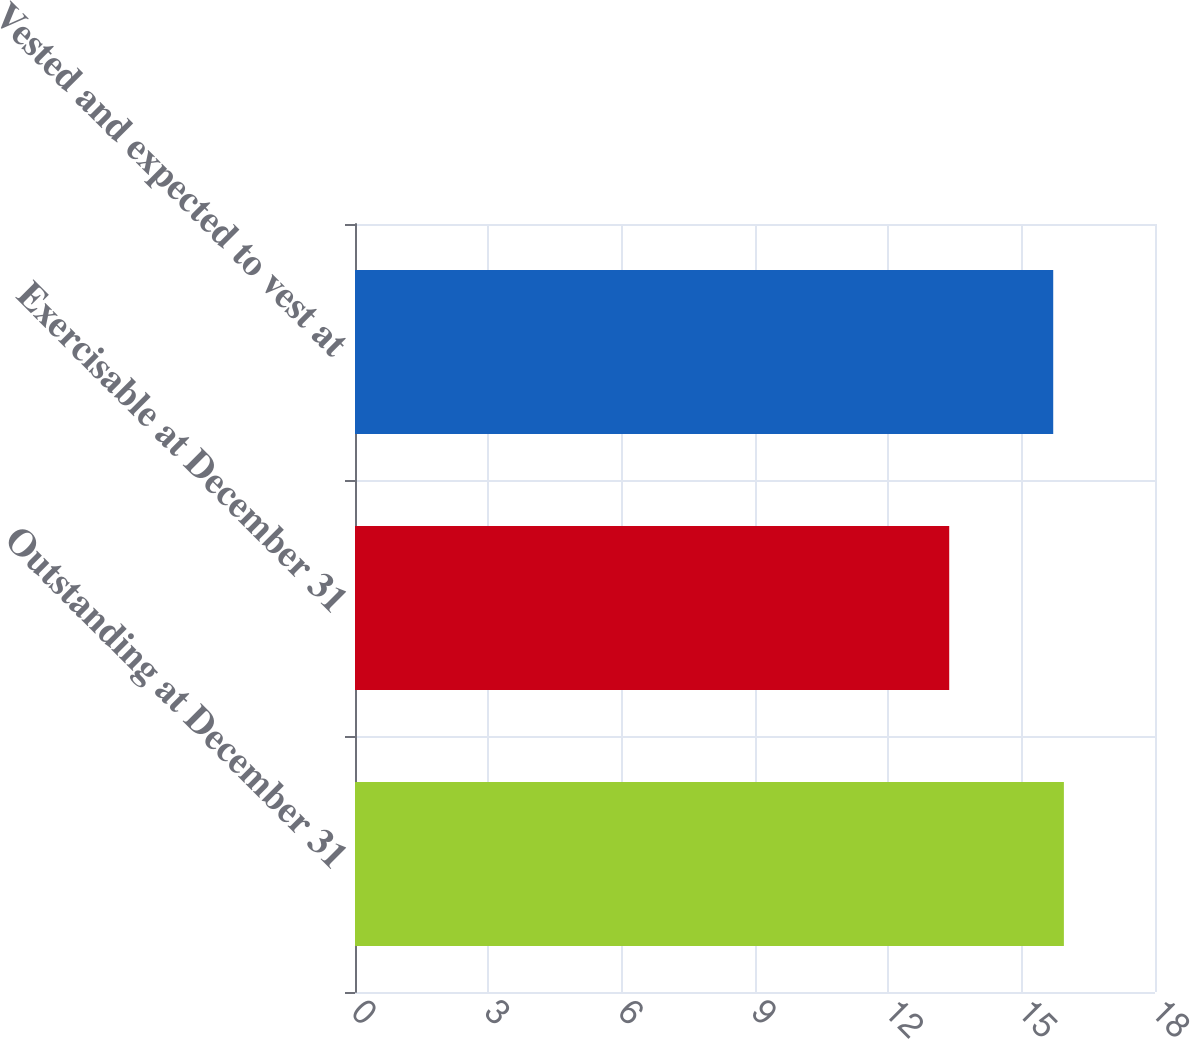<chart> <loc_0><loc_0><loc_500><loc_500><bar_chart><fcel>Outstanding at December 31<fcel>Exercisable at December 31<fcel>Vested and expected to vest at<nl><fcel>15.95<fcel>13.37<fcel>15.71<nl></chart> 